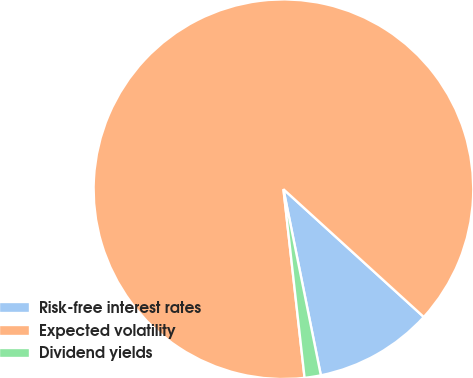Convert chart to OTSL. <chart><loc_0><loc_0><loc_500><loc_500><pie_chart><fcel>Risk-free interest rates<fcel>Expected volatility<fcel>Dividend yields<nl><fcel>10.09%<fcel>88.53%<fcel>1.38%<nl></chart> 